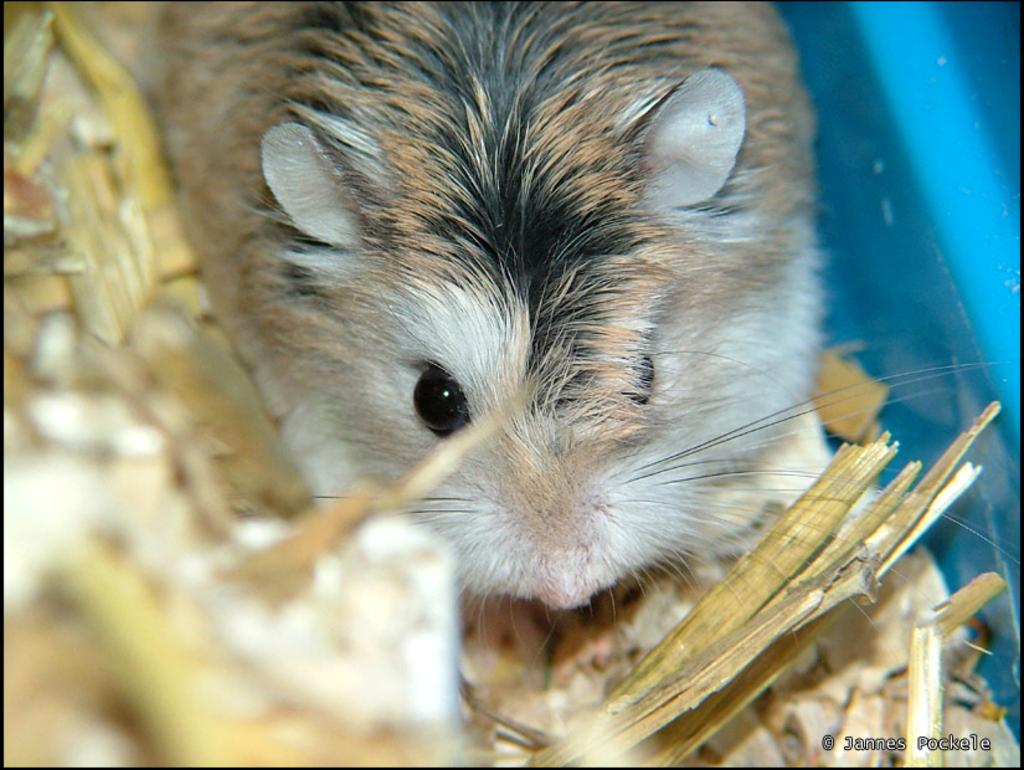What type of animal is in the image? The type of animal cannot be determined from the provided facts. What is the material of the pieces surrounding the animal? The pieces surrounding the animal are made of wood. What type of cork is the animal using to express its beliefs in the image? There is no cork or expression of beliefs present in the image. 